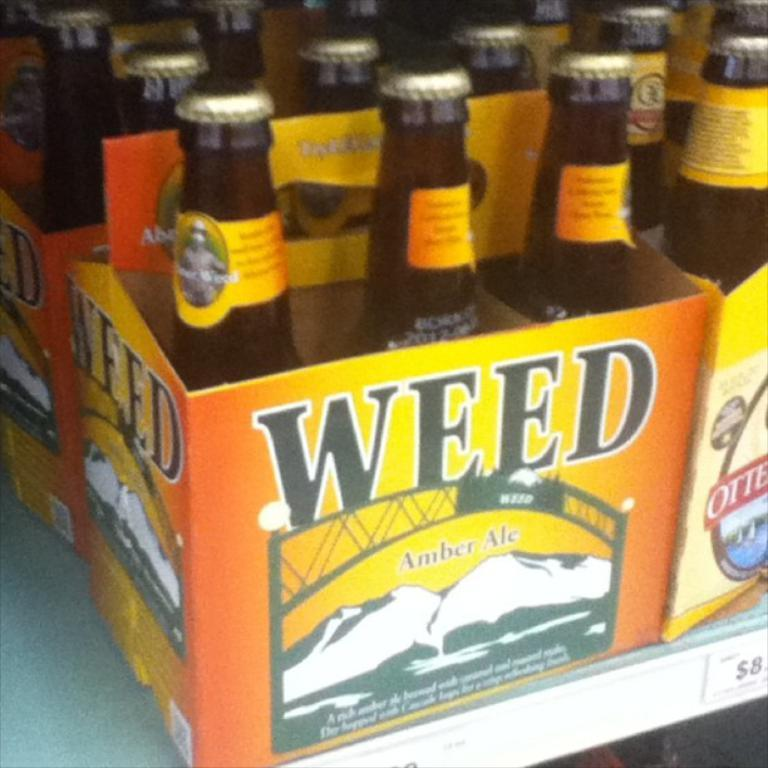<image>
Render a clear and concise summary of the photo. A carton of beer called WEED sits on a shelf. 